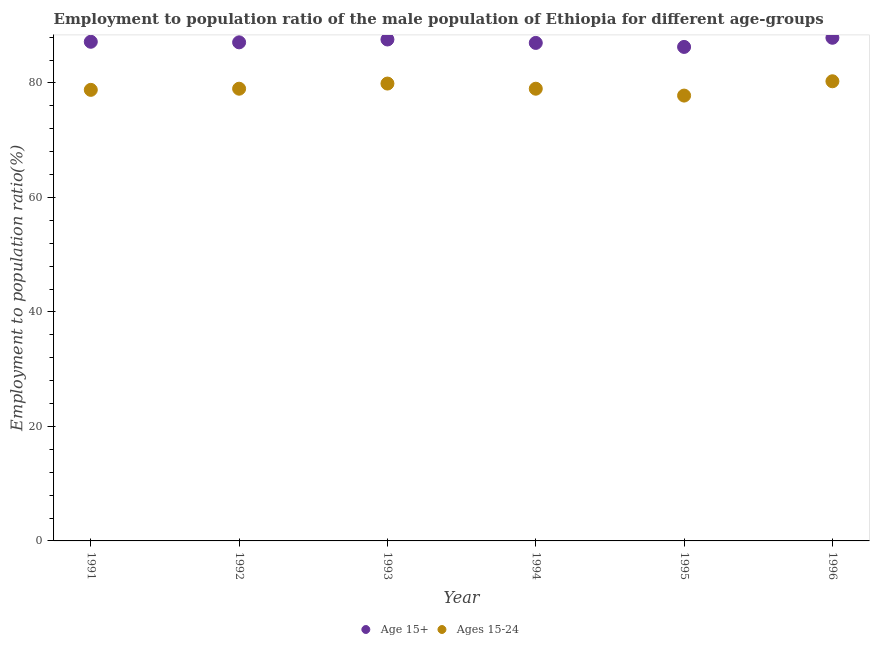How many different coloured dotlines are there?
Provide a short and direct response. 2. What is the employment to population ratio(age 15+) in 1992?
Your answer should be very brief. 87.1. Across all years, what is the maximum employment to population ratio(age 15-24)?
Offer a terse response. 80.3. Across all years, what is the minimum employment to population ratio(age 15-24)?
Offer a terse response. 77.8. In which year was the employment to population ratio(age 15+) minimum?
Make the answer very short. 1995. What is the total employment to population ratio(age 15+) in the graph?
Your answer should be very brief. 523.1. What is the difference between the employment to population ratio(age 15+) in 1991 and that in 1994?
Provide a succinct answer. 0.2. What is the difference between the employment to population ratio(age 15+) in 1991 and the employment to population ratio(age 15-24) in 1992?
Your response must be concise. 8.2. What is the average employment to population ratio(age 15+) per year?
Ensure brevity in your answer.  87.18. In the year 1992, what is the difference between the employment to population ratio(age 15+) and employment to population ratio(age 15-24)?
Provide a short and direct response. 8.1. What is the ratio of the employment to population ratio(age 15-24) in 1992 to that in 1995?
Provide a short and direct response. 1.02. What is the difference between the highest and the second highest employment to population ratio(age 15+)?
Your answer should be compact. 0.3. What is the difference between the highest and the lowest employment to population ratio(age 15+)?
Keep it short and to the point. 1.6. In how many years, is the employment to population ratio(age 15+) greater than the average employment to population ratio(age 15+) taken over all years?
Offer a terse response. 3. Does the employment to population ratio(age 15+) monotonically increase over the years?
Make the answer very short. No. Is the employment to population ratio(age 15+) strictly less than the employment to population ratio(age 15-24) over the years?
Make the answer very short. No. How many dotlines are there?
Offer a very short reply. 2. What is the difference between two consecutive major ticks on the Y-axis?
Keep it short and to the point. 20. Are the values on the major ticks of Y-axis written in scientific E-notation?
Your answer should be compact. No. Does the graph contain any zero values?
Give a very brief answer. No. Does the graph contain grids?
Your answer should be compact. No. How many legend labels are there?
Offer a very short reply. 2. How are the legend labels stacked?
Your answer should be compact. Horizontal. What is the title of the graph?
Make the answer very short. Employment to population ratio of the male population of Ethiopia for different age-groups. What is the label or title of the X-axis?
Make the answer very short. Year. What is the label or title of the Y-axis?
Make the answer very short. Employment to population ratio(%). What is the Employment to population ratio(%) in Age 15+ in 1991?
Your answer should be very brief. 87.2. What is the Employment to population ratio(%) of Ages 15-24 in 1991?
Make the answer very short. 78.8. What is the Employment to population ratio(%) in Age 15+ in 1992?
Provide a succinct answer. 87.1. What is the Employment to population ratio(%) in Ages 15-24 in 1992?
Offer a very short reply. 79. What is the Employment to population ratio(%) in Age 15+ in 1993?
Give a very brief answer. 87.6. What is the Employment to population ratio(%) of Ages 15-24 in 1993?
Offer a very short reply. 79.9. What is the Employment to population ratio(%) in Ages 15-24 in 1994?
Your answer should be very brief. 79. What is the Employment to population ratio(%) in Age 15+ in 1995?
Your answer should be compact. 86.3. What is the Employment to population ratio(%) of Ages 15-24 in 1995?
Your response must be concise. 77.8. What is the Employment to population ratio(%) of Age 15+ in 1996?
Your answer should be very brief. 87.9. What is the Employment to population ratio(%) in Ages 15-24 in 1996?
Offer a terse response. 80.3. Across all years, what is the maximum Employment to population ratio(%) in Age 15+?
Your answer should be very brief. 87.9. Across all years, what is the maximum Employment to population ratio(%) of Ages 15-24?
Make the answer very short. 80.3. Across all years, what is the minimum Employment to population ratio(%) of Age 15+?
Provide a short and direct response. 86.3. Across all years, what is the minimum Employment to population ratio(%) in Ages 15-24?
Provide a succinct answer. 77.8. What is the total Employment to population ratio(%) in Age 15+ in the graph?
Offer a very short reply. 523.1. What is the total Employment to population ratio(%) in Ages 15-24 in the graph?
Offer a very short reply. 474.8. What is the difference between the Employment to population ratio(%) in Age 15+ in 1991 and that in 1992?
Your answer should be compact. 0.1. What is the difference between the Employment to population ratio(%) of Ages 15-24 in 1991 and that in 1992?
Provide a succinct answer. -0.2. What is the difference between the Employment to population ratio(%) in Ages 15-24 in 1991 and that in 1994?
Offer a terse response. -0.2. What is the difference between the Employment to population ratio(%) of Ages 15-24 in 1991 and that in 1995?
Give a very brief answer. 1. What is the difference between the Employment to population ratio(%) in Ages 15-24 in 1991 and that in 1996?
Provide a succinct answer. -1.5. What is the difference between the Employment to population ratio(%) in Age 15+ in 1992 and that in 1993?
Keep it short and to the point. -0.5. What is the difference between the Employment to population ratio(%) in Age 15+ in 1992 and that in 1994?
Give a very brief answer. 0.1. What is the difference between the Employment to population ratio(%) in Age 15+ in 1992 and that in 1995?
Provide a short and direct response. 0.8. What is the difference between the Employment to population ratio(%) of Ages 15-24 in 1993 and that in 1994?
Offer a very short reply. 0.9. What is the difference between the Employment to population ratio(%) of Age 15+ in 1993 and that in 1995?
Offer a terse response. 1.3. What is the difference between the Employment to population ratio(%) of Ages 15-24 in 1993 and that in 1995?
Your response must be concise. 2.1. What is the difference between the Employment to population ratio(%) in Age 15+ in 1994 and that in 1995?
Provide a succinct answer. 0.7. What is the difference between the Employment to population ratio(%) of Age 15+ in 1995 and that in 1996?
Give a very brief answer. -1.6. What is the difference between the Employment to population ratio(%) in Age 15+ in 1991 and the Employment to population ratio(%) in Ages 15-24 in 1992?
Your answer should be very brief. 8.2. What is the difference between the Employment to population ratio(%) in Age 15+ in 1991 and the Employment to population ratio(%) in Ages 15-24 in 1993?
Offer a very short reply. 7.3. What is the difference between the Employment to population ratio(%) of Age 15+ in 1991 and the Employment to population ratio(%) of Ages 15-24 in 1994?
Give a very brief answer. 8.2. What is the difference between the Employment to population ratio(%) in Age 15+ in 1991 and the Employment to population ratio(%) in Ages 15-24 in 1995?
Your answer should be compact. 9.4. What is the difference between the Employment to population ratio(%) of Age 15+ in 1991 and the Employment to population ratio(%) of Ages 15-24 in 1996?
Give a very brief answer. 6.9. What is the difference between the Employment to population ratio(%) of Age 15+ in 1992 and the Employment to population ratio(%) of Ages 15-24 in 1994?
Offer a terse response. 8.1. What is the difference between the Employment to population ratio(%) in Age 15+ in 1993 and the Employment to population ratio(%) in Ages 15-24 in 1996?
Provide a succinct answer. 7.3. What is the difference between the Employment to population ratio(%) of Age 15+ in 1994 and the Employment to population ratio(%) of Ages 15-24 in 1995?
Your answer should be very brief. 9.2. What is the difference between the Employment to population ratio(%) of Age 15+ in 1994 and the Employment to population ratio(%) of Ages 15-24 in 1996?
Keep it short and to the point. 6.7. What is the average Employment to population ratio(%) in Age 15+ per year?
Your answer should be very brief. 87.18. What is the average Employment to population ratio(%) of Ages 15-24 per year?
Provide a short and direct response. 79.13. In the year 1991, what is the difference between the Employment to population ratio(%) of Age 15+ and Employment to population ratio(%) of Ages 15-24?
Offer a terse response. 8.4. In the year 1992, what is the difference between the Employment to population ratio(%) of Age 15+ and Employment to population ratio(%) of Ages 15-24?
Your answer should be very brief. 8.1. In the year 1993, what is the difference between the Employment to population ratio(%) in Age 15+ and Employment to population ratio(%) in Ages 15-24?
Your answer should be very brief. 7.7. In the year 1994, what is the difference between the Employment to population ratio(%) of Age 15+ and Employment to population ratio(%) of Ages 15-24?
Your answer should be very brief. 8. In the year 1995, what is the difference between the Employment to population ratio(%) in Age 15+ and Employment to population ratio(%) in Ages 15-24?
Your answer should be very brief. 8.5. What is the ratio of the Employment to population ratio(%) of Age 15+ in 1991 to that in 1992?
Make the answer very short. 1. What is the ratio of the Employment to population ratio(%) of Ages 15-24 in 1991 to that in 1992?
Your answer should be very brief. 1. What is the ratio of the Employment to population ratio(%) in Ages 15-24 in 1991 to that in 1993?
Your answer should be very brief. 0.99. What is the ratio of the Employment to population ratio(%) in Age 15+ in 1991 to that in 1994?
Provide a succinct answer. 1. What is the ratio of the Employment to population ratio(%) in Ages 15-24 in 1991 to that in 1994?
Provide a short and direct response. 1. What is the ratio of the Employment to population ratio(%) in Age 15+ in 1991 to that in 1995?
Ensure brevity in your answer.  1.01. What is the ratio of the Employment to population ratio(%) of Ages 15-24 in 1991 to that in 1995?
Give a very brief answer. 1.01. What is the ratio of the Employment to population ratio(%) of Ages 15-24 in 1991 to that in 1996?
Give a very brief answer. 0.98. What is the ratio of the Employment to population ratio(%) in Age 15+ in 1992 to that in 1993?
Your answer should be very brief. 0.99. What is the ratio of the Employment to population ratio(%) of Ages 15-24 in 1992 to that in 1993?
Provide a short and direct response. 0.99. What is the ratio of the Employment to population ratio(%) of Age 15+ in 1992 to that in 1994?
Your answer should be very brief. 1. What is the ratio of the Employment to population ratio(%) in Ages 15-24 in 1992 to that in 1994?
Offer a terse response. 1. What is the ratio of the Employment to population ratio(%) in Age 15+ in 1992 to that in 1995?
Give a very brief answer. 1.01. What is the ratio of the Employment to population ratio(%) of Ages 15-24 in 1992 to that in 1995?
Keep it short and to the point. 1.02. What is the ratio of the Employment to population ratio(%) of Age 15+ in 1992 to that in 1996?
Your answer should be compact. 0.99. What is the ratio of the Employment to population ratio(%) of Ages 15-24 in 1992 to that in 1996?
Ensure brevity in your answer.  0.98. What is the ratio of the Employment to population ratio(%) in Ages 15-24 in 1993 to that in 1994?
Keep it short and to the point. 1.01. What is the ratio of the Employment to population ratio(%) in Age 15+ in 1993 to that in 1995?
Make the answer very short. 1.02. What is the ratio of the Employment to population ratio(%) in Ages 15-24 in 1994 to that in 1995?
Your answer should be very brief. 1.02. What is the ratio of the Employment to population ratio(%) of Age 15+ in 1994 to that in 1996?
Give a very brief answer. 0.99. What is the ratio of the Employment to population ratio(%) of Ages 15-24 in 1994 to that in 1996?
Make the answer very short. 0.98. What is the ratio of the Employment to population ratio(%) in Age 15+ in 1995 to that in 1996?
Offer a terse response. 0.98. What is the ratio of the Employment to population ratio(%) of Ages 15-24 in 1995 to that in 1996?
Keep it short and to the point. 0.97. What is the difference between the highest and the lowest Employment to population ratio(%) of Age 15+?
Provide a short and direct response. 1.6. What is the difference between the highest and the lowest Employment to population ratio(%) of Ages 15-24?
Offer a terse response. 2.5. 